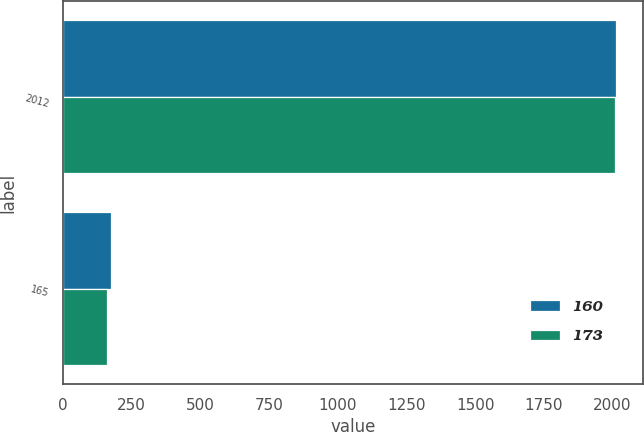<chart> <loc_0><loc_0><loc_500><loc_500><stacked_bar_chart><ecel><fcel>2012<fcel>165<nl><fcel>160<fcel>2011<fcel>173<nl><fcel>173<fcel>2010<fcel>160<nl></chart> 